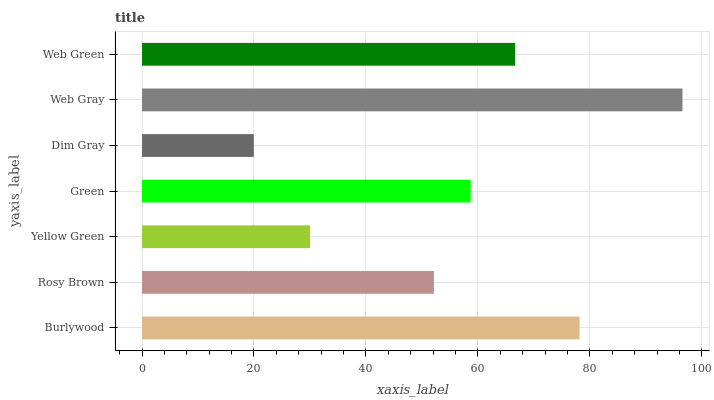Is Dim Gray the minimum?
Answer yes or no. Yes. Is Web Gray the maximum?
Answer yes or no. Yes. Is Rosy Brown the minimum?
Answer yes or no. No. Is Rosy Brown the maximum?
Answer yes or no. No. Is Burlywood greater than Rosy Brown?
Answer yes or no. Yes. Is Rosy Brown less than Burlywood?
Answer yes or no. Yes. Is Rosy Brown greater than Burlywood?
Answer yes or no. No. Is Burlywood less than Rosy Brown?
Answer yes or no. No. Is Green the high median?
Answer yes or no. Yes. Is Green the low median?
Answer yes or no. Yes. Is Dim Gray the high median?
Answer yes or no. No. Is Rosy Brown the low median?
Answer yes or no. No. 